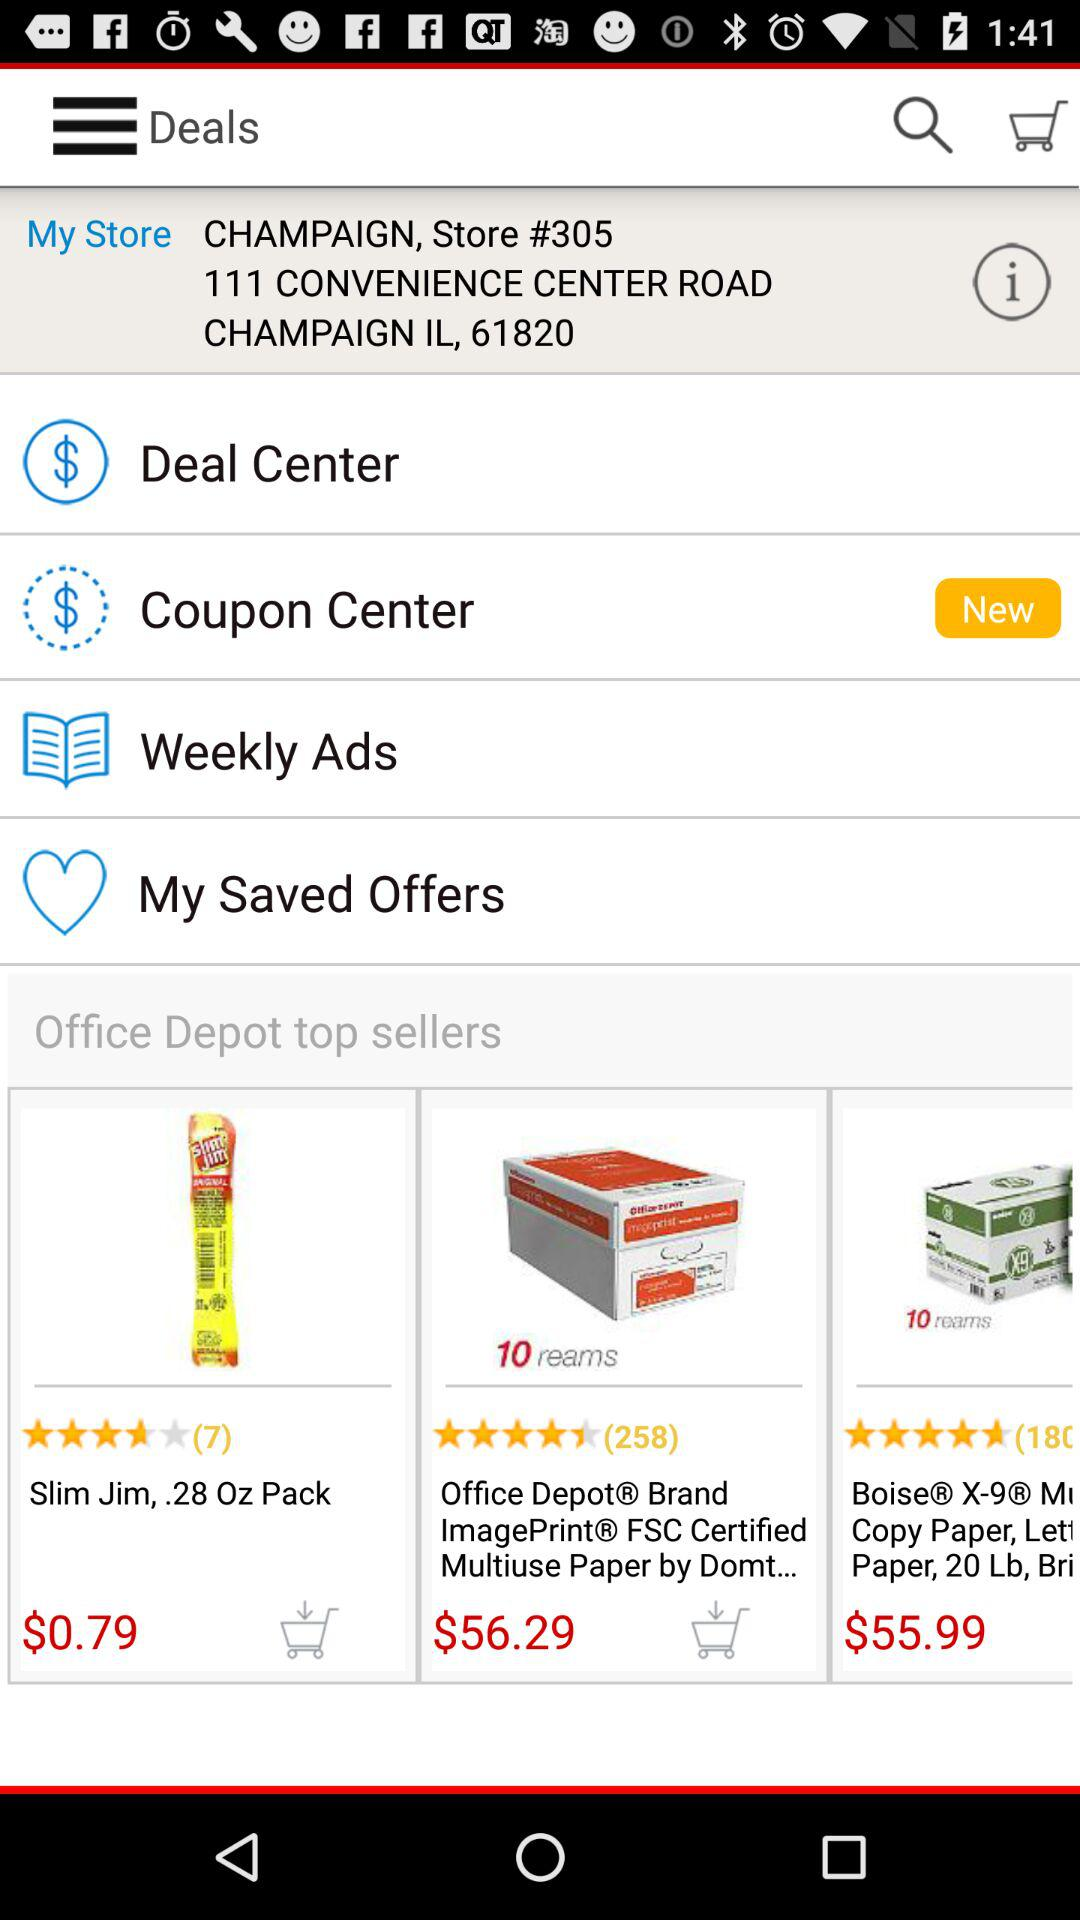What is the cost of Slim Jim? The cost of Slim Jim is $0.79. 